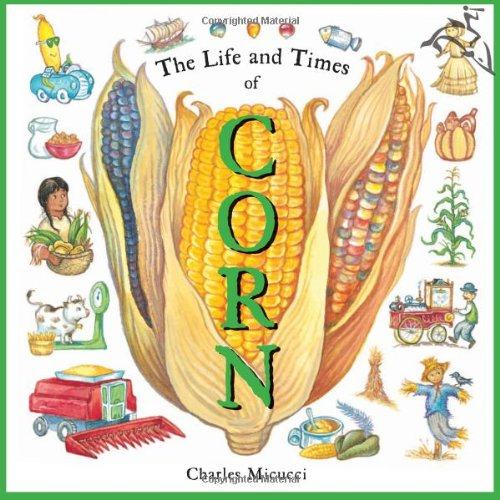Is this a sci-fi book? No, this book is not a sci-fi book. It is an educational children's book that focuses on the real-world history and applications of corn. 